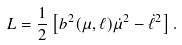Convert formula to latex. <formula><loc_0><loc_0><loc_500><loc_500>L = \frac { 1 } { 2 } \left [ b ^ { 2 } ( \mu , \ell ) \dot { \mu } ^ { 2 } - \dot { \ell } ^ { 2 } \right ] .</formula> 